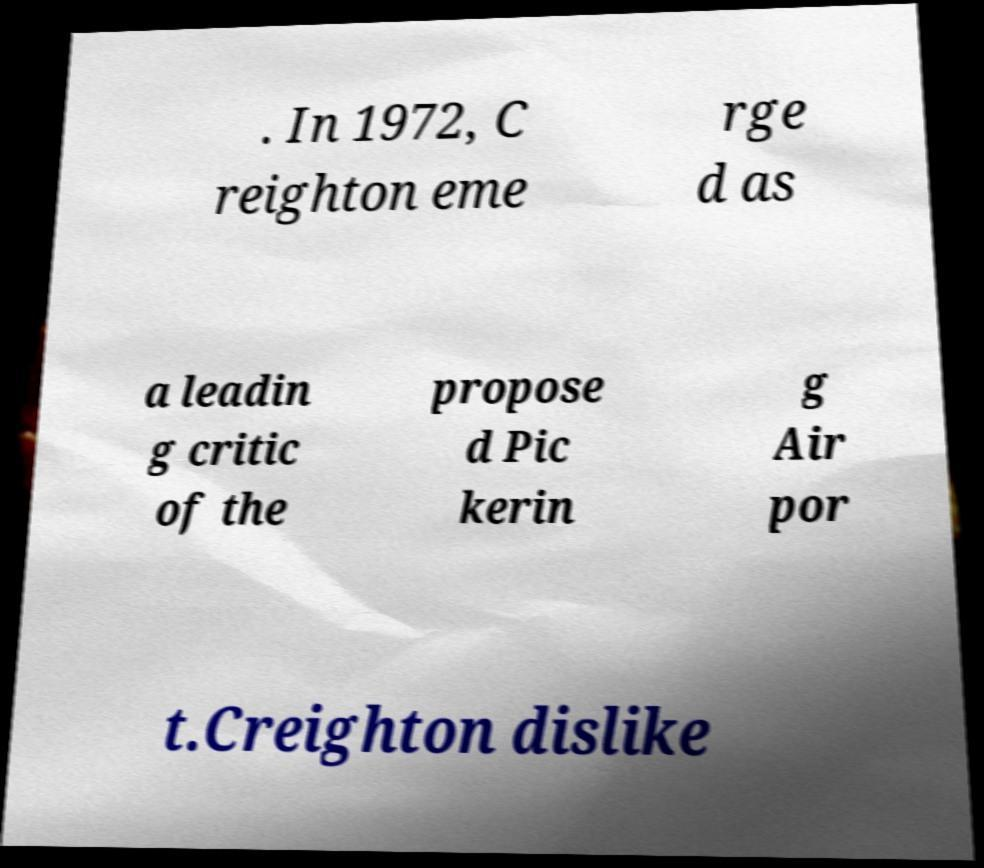I need the written content from this picture converted into text. Can you do that? . In 1972, C reighton eme rge d as a leadin g critic of the propose d Pic kerin g Air por t.Creighton dislike 